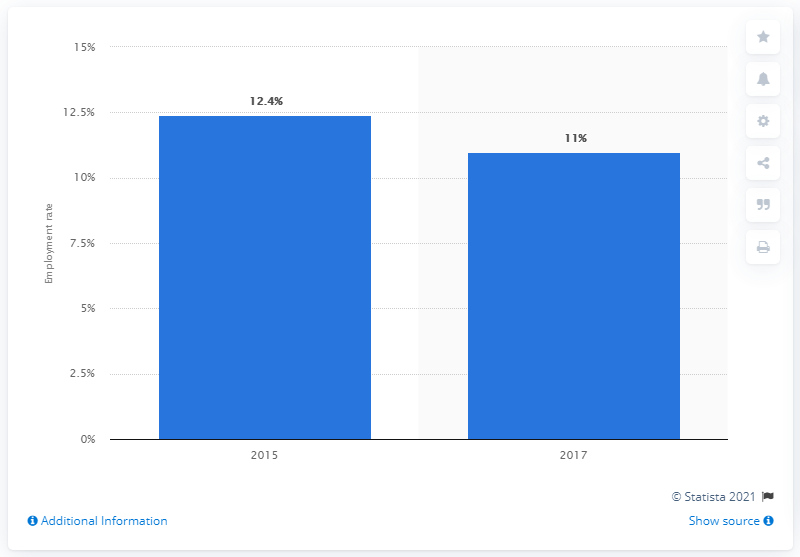List a handful of essential elements in this visual. In 2017, the employment rate among minors in Mexico was 11%. 